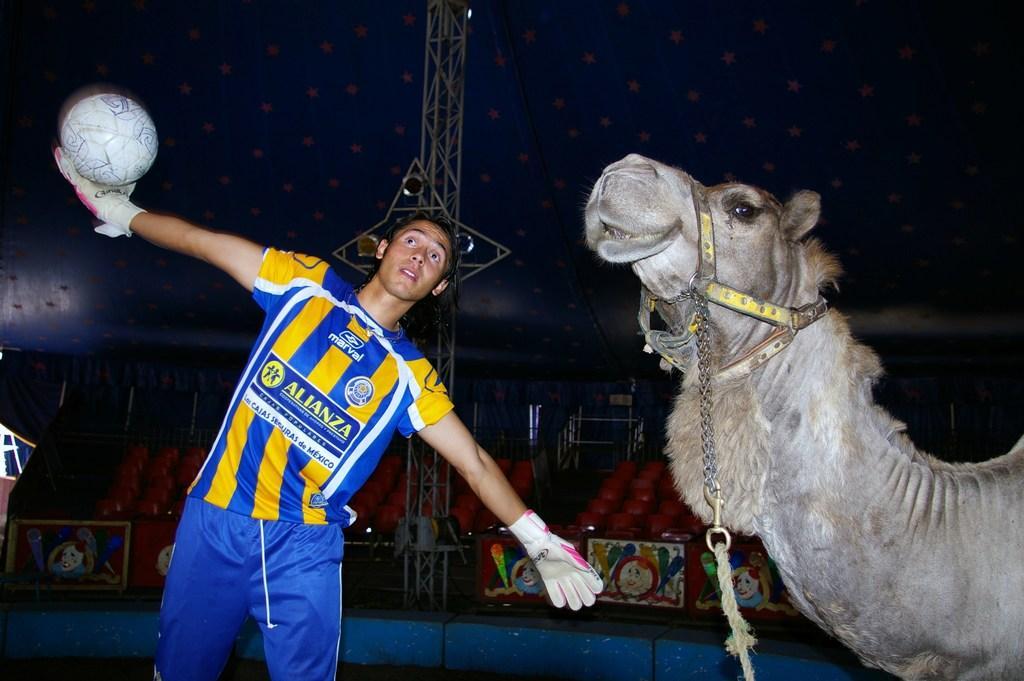How would you summarize this image in a sentence or two? In this picture we can see a person standing and holding a ball, this person wore gloves, on the right side there is a camel, in the background we can see chairs and boards, there are metal rods in the middle. 